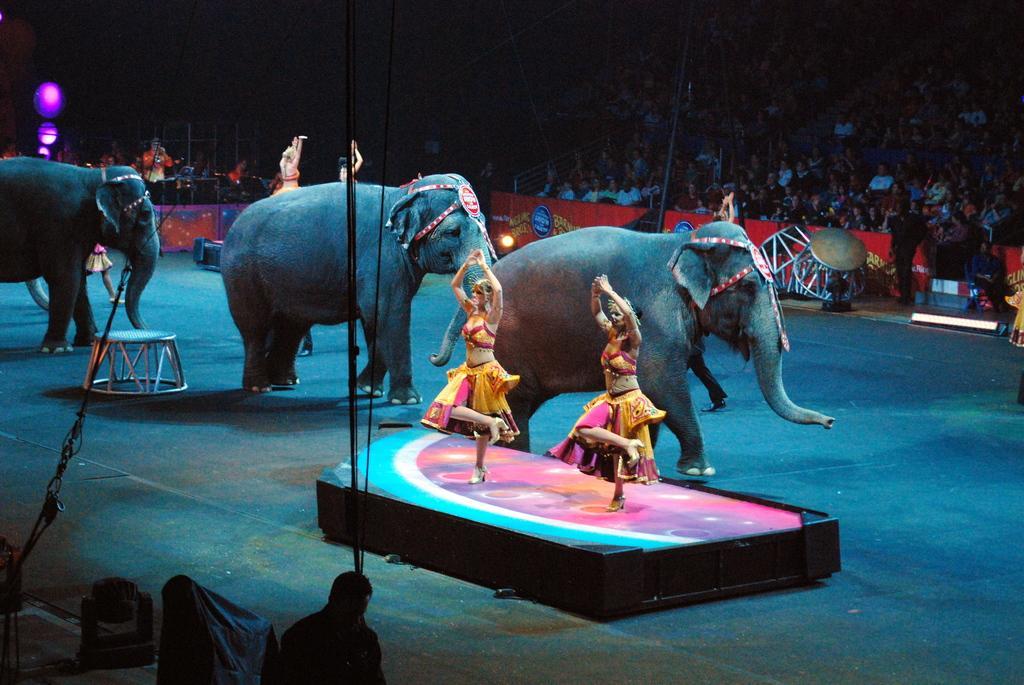Could you give a brief overview of what you see in this image? This picture seems to be clicked inside the hall. In the center we can see the group of persons dancing on the floor and we can see the group of elephants walking on the ground and there are some objects placed on the ground and we can see the ropes. In the background we can see the lights, group of persons and some other objects. 